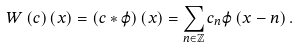Convert formula to latex. <formula><loc_0><loc_0><loc_500><loc_500>W \left ( c \right ) \left ( x \right ) = \left ( c \ast \varphi \right ) \left ( x \right ) = \sum _ { n \in \mathbb { Z } } c _ { n } \varphi \left ( x - n \right ) .</formula> 